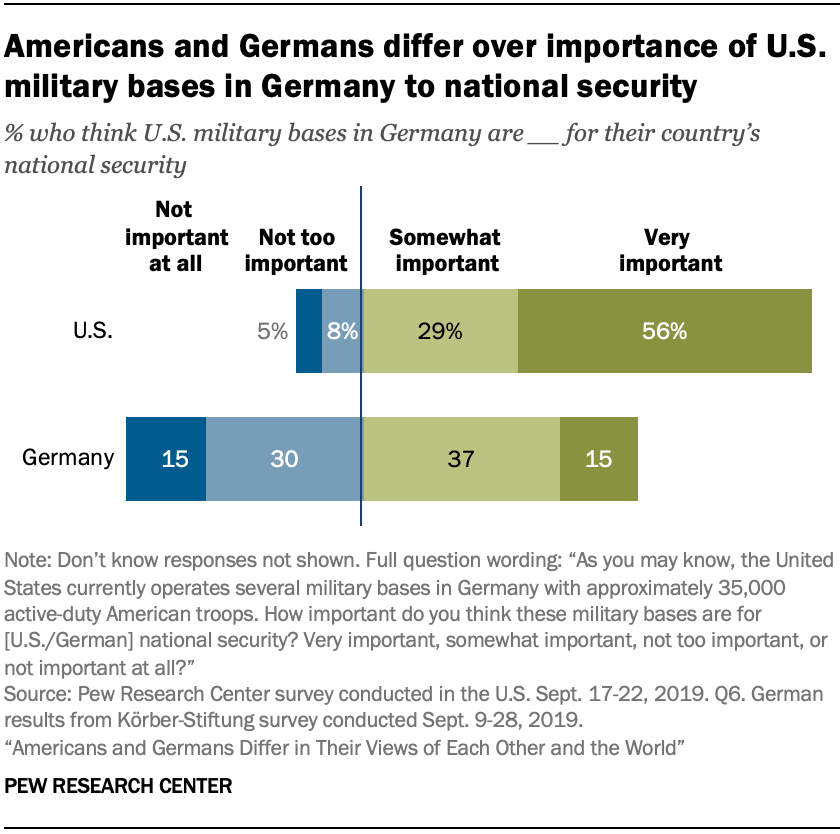Highlight a few significant elements in this photo. The term 'dark green' is defined as extremely important, as indicated by the use of capitalization and punctuation. The average of those who think 'not too important' or 'not important at all' in Germany is 0.225 